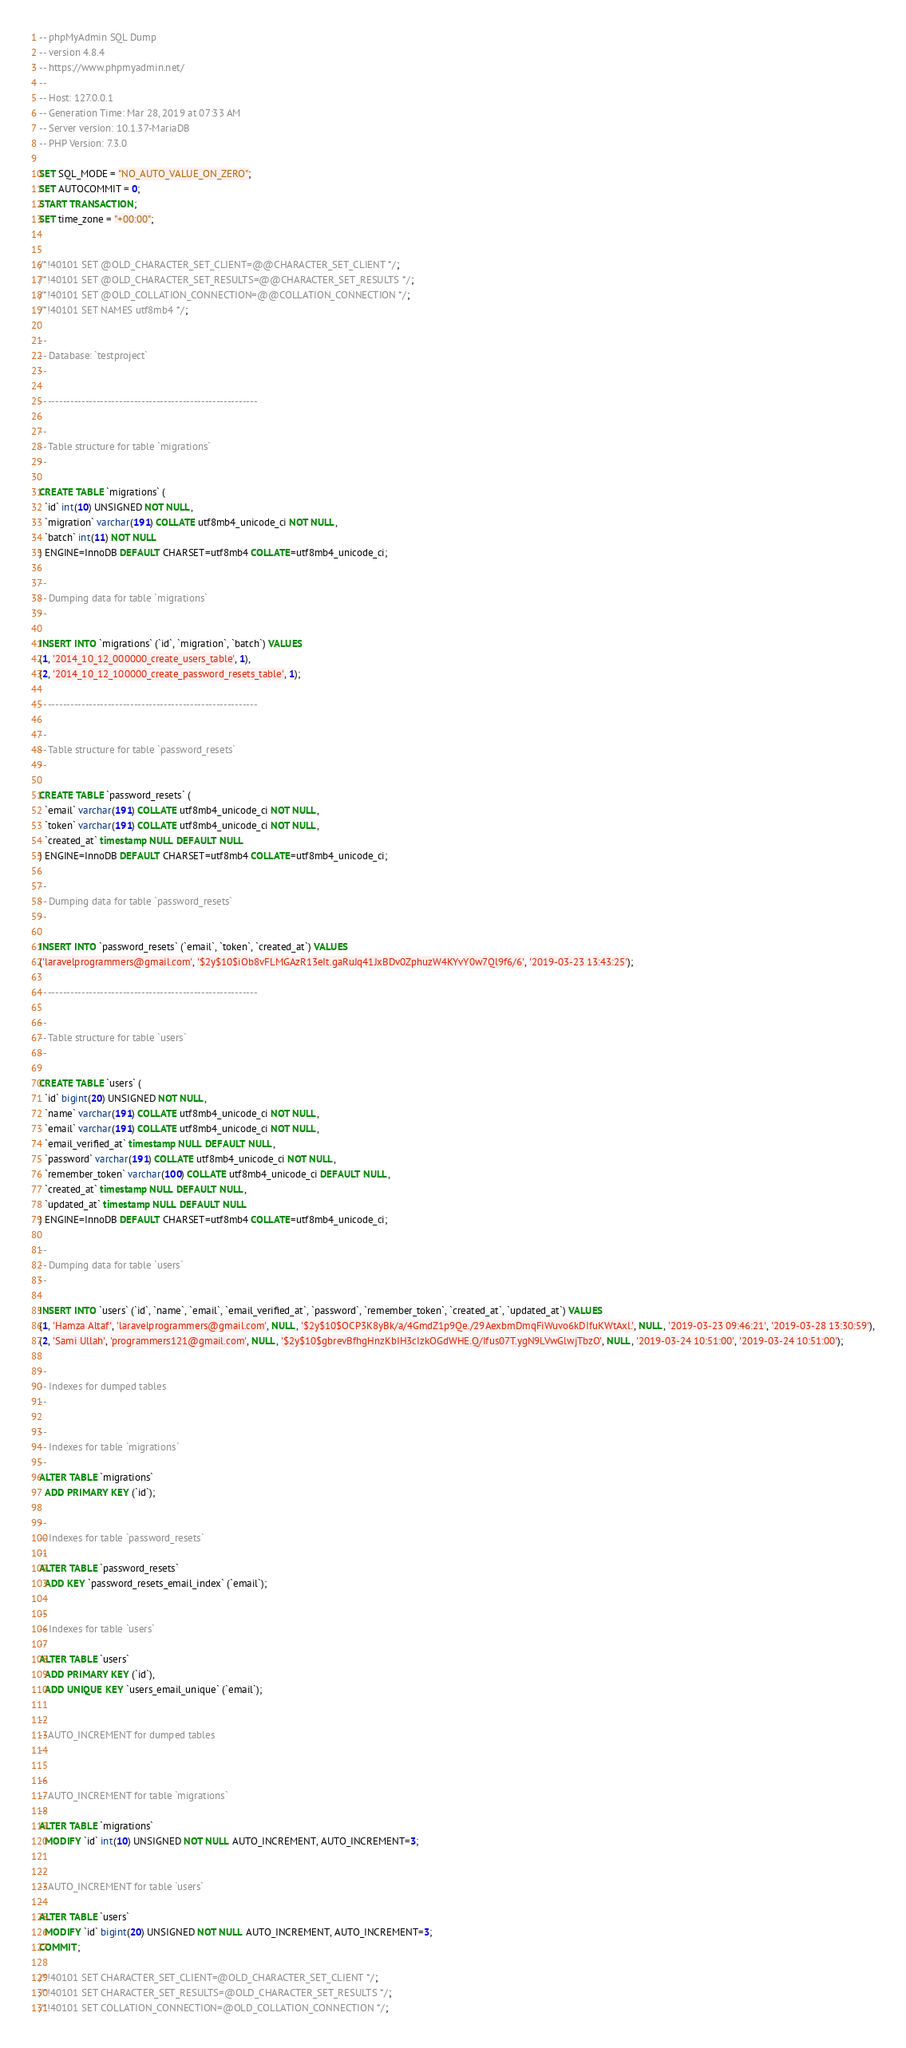Convert code to text. <code><loc_0><loc_0><loc_500><loc_500><_SQL_>-- phpMyAdmin SQL Dump
-- version 4.8.4
-- https://www.phpmyadmin.net/
--
-- Host: 127.0.0.1
-- Generation Time: Mar 28, 2019 at 07:33 AM
-- Server version: 10.1.37-MariaDB
-- PHP Version: 7.3.0

SET SQL_MODE = "NO_AUTO_VALUE_ON_ZERO";
SET AUTOCOMMIT = 0;
START TRANSACTION;
SET time_zone = "+00:00";


/*!40101 SET @OLD_CHARACTER_SET_CLIENT=@@CHARACTER_SET_CLIENT */;
/*!40101 SET @OLD_CHARACTER_SET_RESULTS=@@CHARACTER_SET_RESULTS */;
/*!40101 SET @OLD_COLLATION_CONNECTION=@@COLLATION_CONNECTION */;
/*!40101 SET NAMES utf8mb4 */;

--
-- Database: `testproject`
--

-- --------------------------------------------------------

--
-- Table structure for table `migrations`
--

CREATE TABLE `migrations` (
  `id` int(10) UNSIGNED NOT NULL,
  `migration` varchar(191) COLLATE utf8mb4_unicode_ci NOT NULL,
  `batch` int(11) NOT NULL
) ENGINE=InnoDB DEFAULT CHARSET=utf8mb4 COLLATE=utf8mb4_unicode_ci;

--
-- Dumping data for table `migrations`
--

INSERT INTO `migrations` (`id`, `migration`, `batch`) VALUES
(1, '2014_10_12_000000_create_users_table', 1),
(2, '2014_10_12_100000_create_password_resets_table', 1);

-- --------------------------------------------------------

--
-- Table structure for table `password_resets`
--

CREATE TABLE `password_resets` (
  `email` varchar(191) COLLATE utf8mb4_unicode_ci NOT NULL,
  `token` varchar(191) COLLATE utf8mb4_unicode_ci NOT NULL,
  `created_at` timestamp NULL DEFAULT NULL
) ENGINE=InnoDB DEFAULT CHARSET=utf8mb4 COLLATE=utf8mb4_unicode_ci;

--
-- Dumping data for table `password_resets`
--

INSERT INTO `password_resets` (`email`, `token`, `created_at`) VALUES
('laravelprogrammers@gmail.com', '$2y$10$iOb8vFLMGAzR13eIt.gaRuJq41JxBDv0ZphuzW4KYvY0w7Ql9f6/6', '2019-03-23 13:43:25');

-- --------------------------------------------------------

--
-- Table structure for table `users`
--

CREATE TABLE `users` (
  `id` bigint(20) UNSIGNED NOT NULL,
  `name` varchar(191) COLLATE utf8mb4_unicode_ci NOT NULL,
  `email` varchar(191) COLLATE utf8mb4_unicode_ci NOT NULL,
  `email_verified_at` timestamp NULL DEFAULT NULL,
  `password` varchar(191) COLLATE utf8mb4_unicode_ci NOT NULL,
  `remember_token` varchar(100) COLLATE utf8mb4_unicode_ci DEFAULT NULL,
  `created_at` timestamp NULL DEFAULT NULL,
  `updated_at` timestamp NULL DEFAULT NULL
) ENGINE=InnoDB DEFAULT CHARSET=utf8mb4 COLLATE=utf8mb4_unicode_ci;

--
-- Dumping data for table `users`
--

INSERT INTO `users` (`id`, `name`, `email`, `email_verified_at`, `password`, `remember_token`, `created_at`, `updated_at`) VALUES
(1, 'Hamza Altaf', 'laravelprogrammers@gmail.com', NULL, '$2y$10$OCP3K8yBk/a/4GmdZ1p9Qe./29AexbmDmqFiWuvo6kDIfuKWtAxl.', NULL, '2019-03-23 09:46:21', '2019-03-28 13:30:59'),
(2, 'Sami Ullah', 'programmers121@gmail.com', NULL, '$2y$10$gbrevBfhgHnzKbIH3cIzkOGdWHE.Q/Ifus07T.ygN9LVwGlwjTbzO', NULL, '2019-03-24 10:51:00', '2019-03-24 10:51:00');

--
-- Indexes for dumped tables
--

--
-- Indexes for table `migrations`
--
ALTER TABLE `migrations`
  ADD PRIMARY KEY (`id`);

--
-- Indexes for table `password_resets`
--
ALTER TABLE `password_resets`
  ADD KEY `password_resets_email_index` (`email`);

--
-- Indexes for table `users`
--
ALTER TABLE `users`
  ADD PRIMARY KEY (`id`),
  ADD UNIQUE KEY `users_email_unique` (`email`);

--
-- AUTO_INCREMENT for dumped tables
--

--
-- AUTO_INCREMENT for table `migrations`
--
ALTER TABLE `migrations`
  MODIFY `id` int(10) UNSIGNED NOT NULL AUTO_INCREMENT, AUTO_INCREMENT=3;

--
-- AUTO_INCREMENT for table `users`
--
ALTER TABLE `users`
  MODIFY `id` bigint(20) UNSIGNED NOT NULL AUTO_INCREMENT, AUTO_INCREMENT=3;
COMMIT;

/*!40101 SET CHARACTER_SET_CLIENT=@OLD_CHARACTER_SET_CLIENT */;
/*!40101 SET CHARACTER_SET_RESULTS=@OLD_CHARACTER_SET_RESULTS */;
/*!40101 SET COLLATION_CONNECTION=@OLD_COLLATION_CONNECTION */;
</code> 